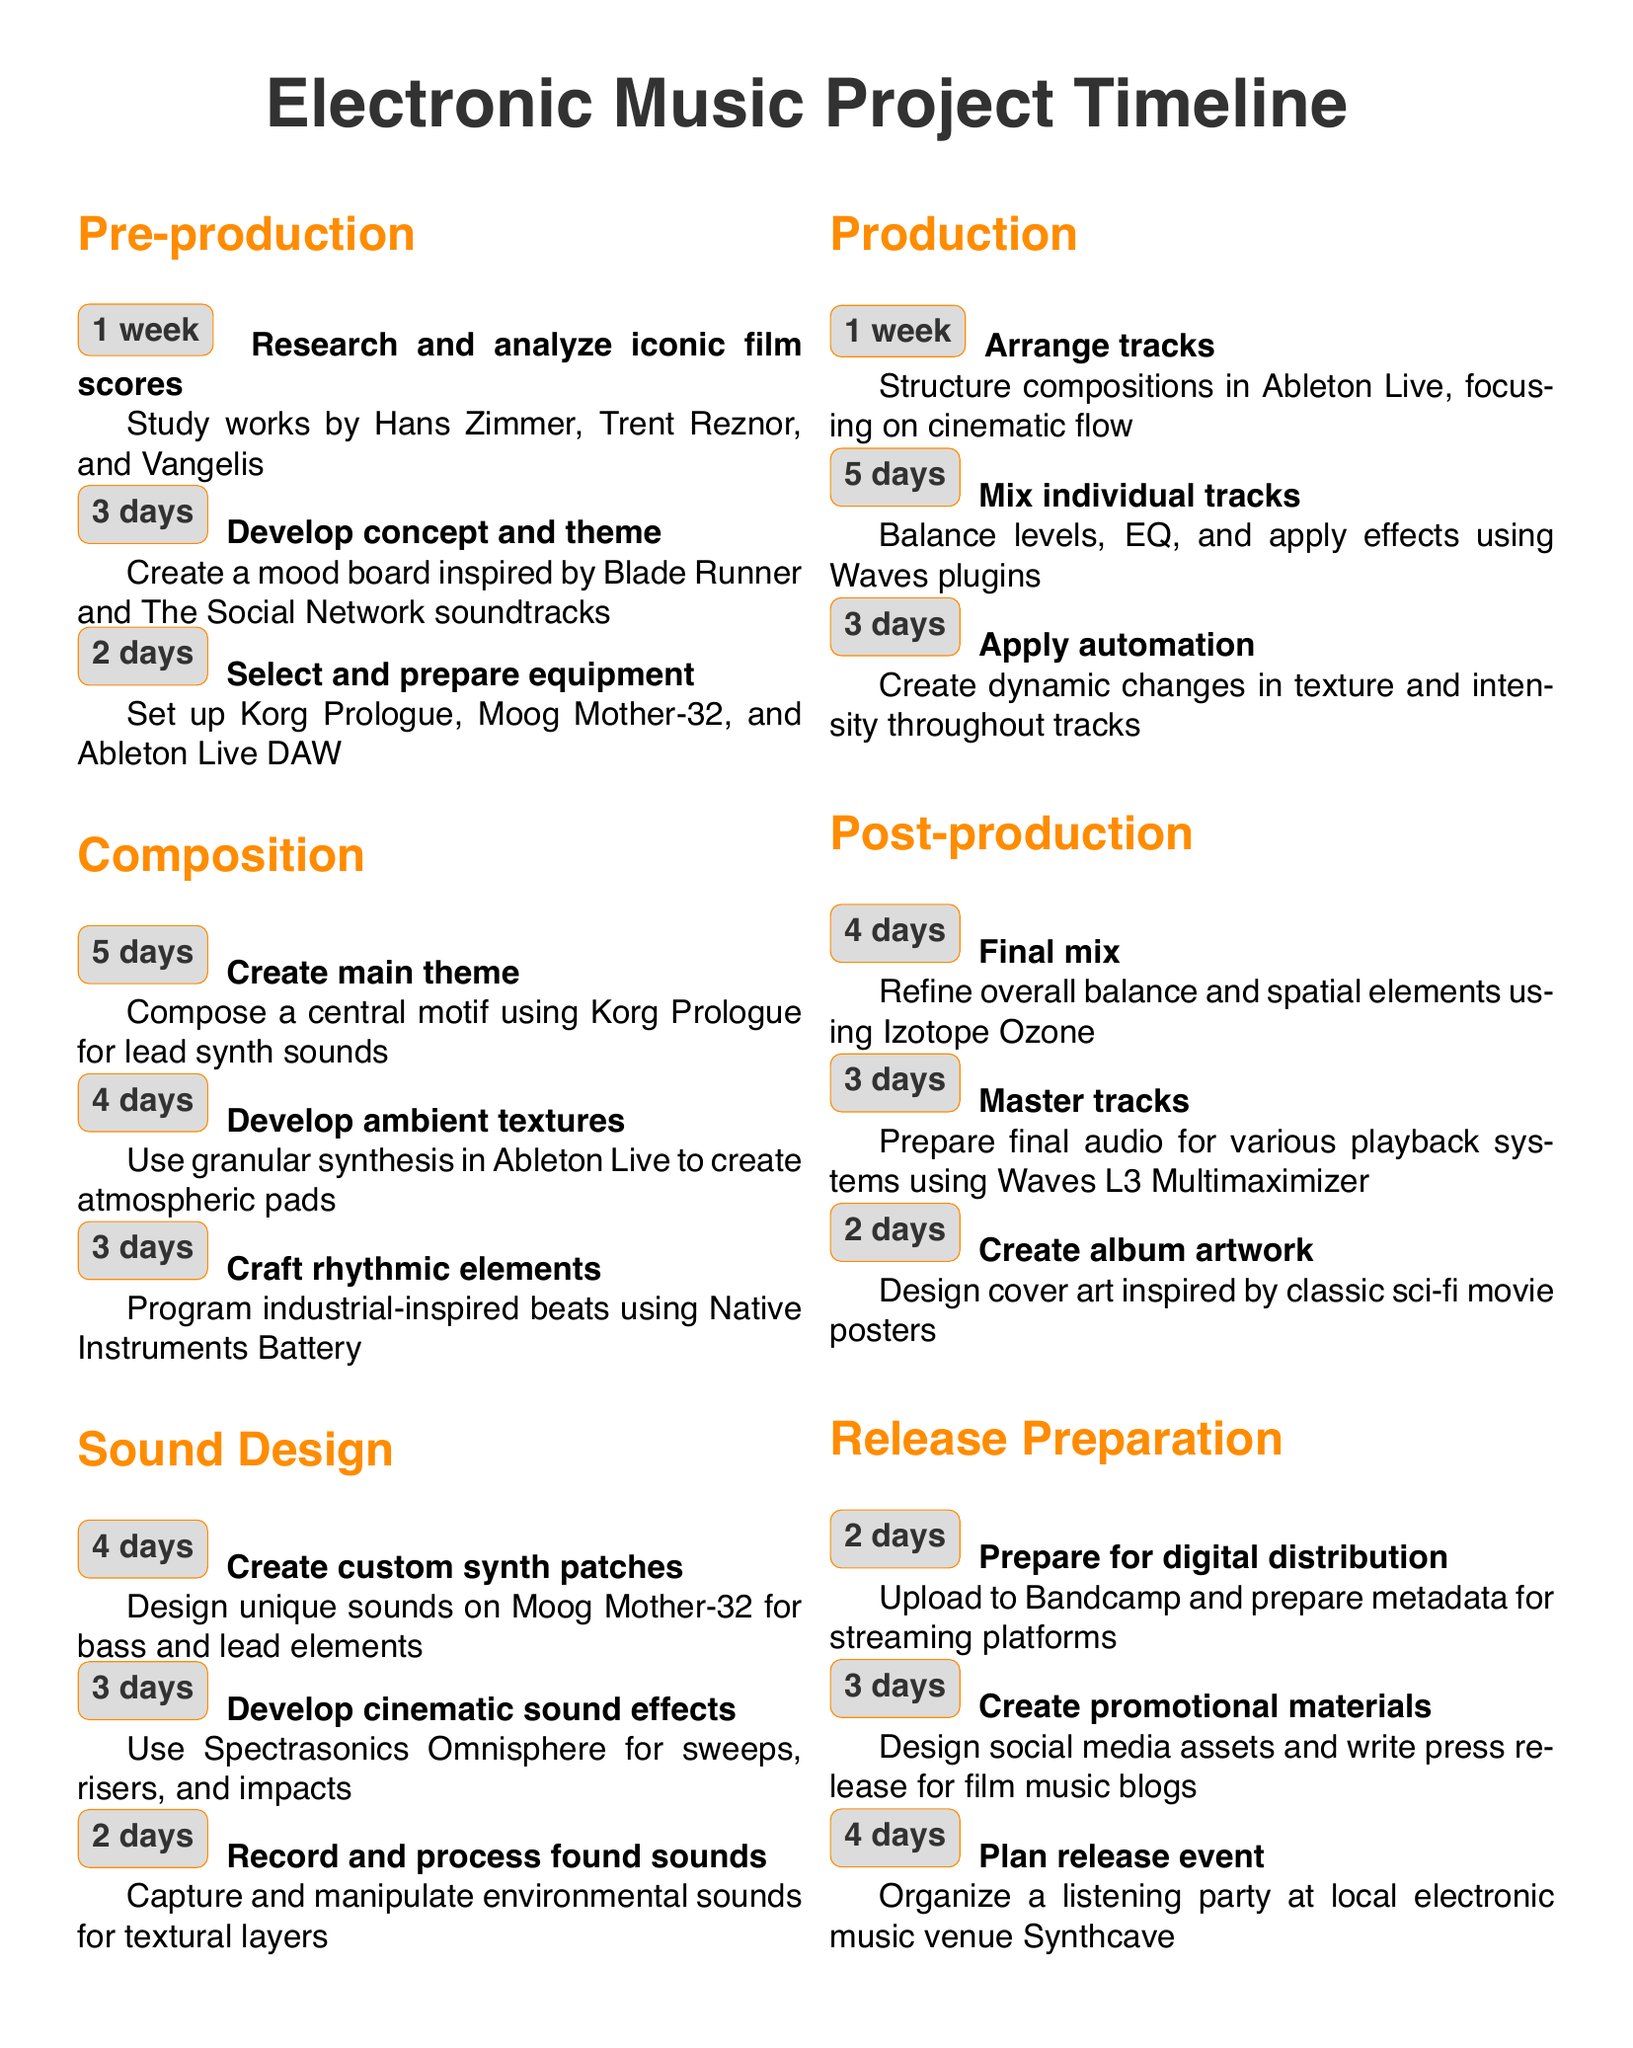What is the duration of the pre-production phase? The pre-production phase includes tasks with a total duration of 1 week, 3 days, and 2 days.
Answer: 1 week Who are the composers studied during research? The research task specifies studying works by Hans Zimmer, Trent Reznor, and Vangelis.
Answer: Hans Zimmer, Trent Reznor, and Vangelis How many days are allocated for the final mix? The final mix task is listed in the post-production phase and takes 4 days.
Answer: 4 days What is the main equipment prepared during pre-production? The equipment selected includes Korg Prologue, Moog Mother-32, and Ableton Live DAW.
Answer: Korg Prologue, Moog Mother-32, and Ableton Live DAW How long is the composition phase in total? The duration of the composition phase involves 5 days, 4 days, and 3 days, totaling 12 days.
Answer: 12 days Which software is used for mixing individual tracks? The mixing task specifies using Waves plugins for balancing levels and effects.
Answer: Waves plugins What phase includes arranging tracks? Arranging tracks occurs in the production phase of the project.
Answer: Production What type of sound effects are developed in the sound design phase? The task specifies developing cinematic sound effects using Spectrasonics Omnisphere.
Answer: Cinematic sound effects How many days are allocated to plan the release event? The task of planning the release event takes 4 days in the release preparation phase.
Answer: 4 days 